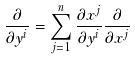Convert formula to latex. <formula><loc_0><loc_0><loc_500><loc_500>\frac { \partial } { \partial y ^ { i } } = \sum _ { j = 1 } ^ { n } \frac { \partial x ^ { j } } { \partial y ^ { i } } \frac { \partial } { \partial x ^ { j } }</formula> 